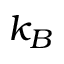Convert formula to latex. <formula><loc_0><loc_0><loc_500><loc_500>k _ { B }</formula> 